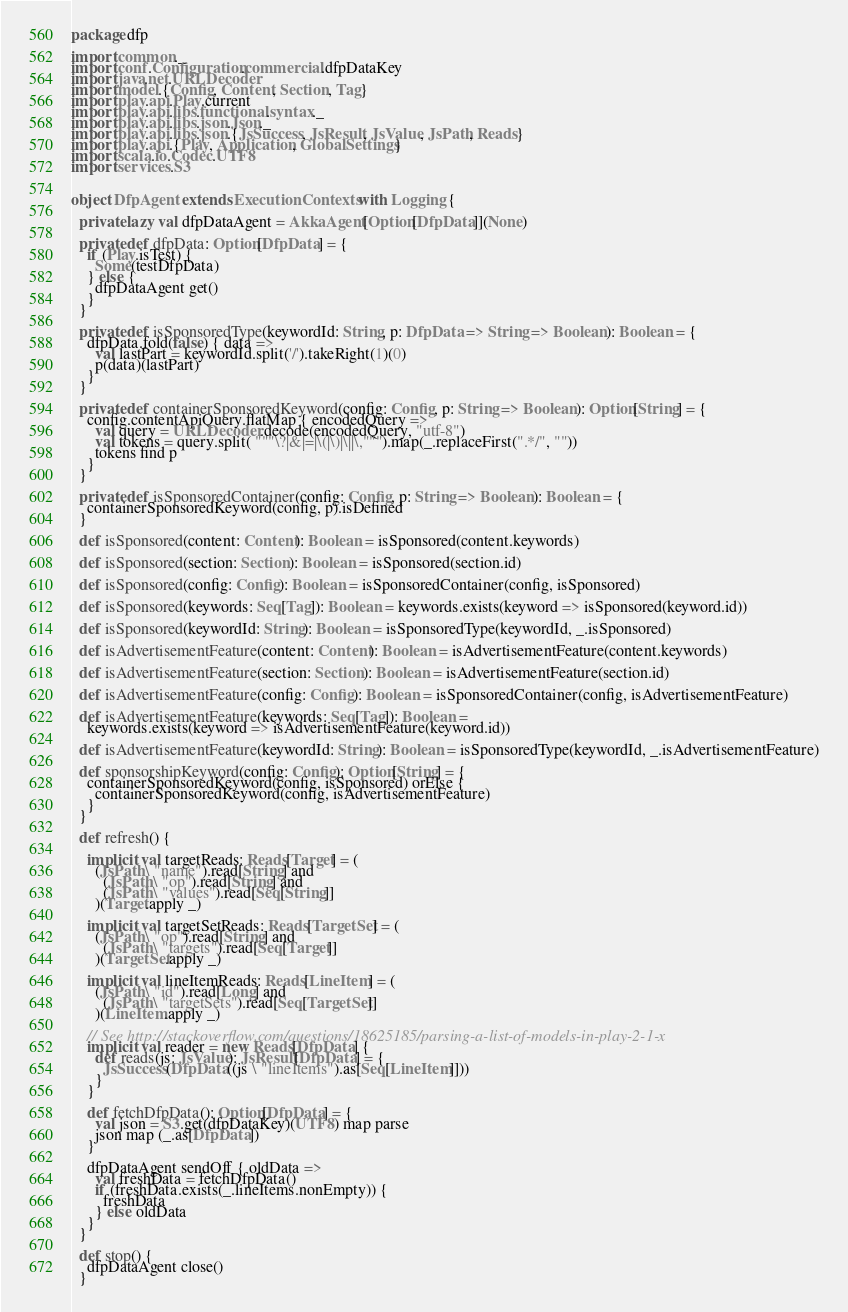<code> <loc_0><loc_0><loc_500><loc_500><_Scala_>package dfp

import common._
import conf.Configuration.commercial.dfpDataKey
import java.net.URLDecoder
import model.{Config, Content, Section, Tag}
import play.api.Play.current
import play.api.libs.functional.syntax._
import play.api.libs.json.Json._
import play.api.libs.json.{JsSuccess, JsResult, JsValue, JsPath, Reads}
import play.api.{Play, Application, GlobalSettings}
import scala.io.Codec.UTF8
import services.S3


object DfpAgent extends ExecutionContexts with Logging {

  private lazy val dfpDataAgent = AkkaAgent[Option[DfpData]](None)

  private def dfpData: Option[DfpData] = {
    if (Play.isTest) {
      Some(testDfpData)
    } else {
      dfpDataAgent get()
    }
  }

  private def isSponsoredType(keywordId: String, p: DfpData => String => Boolean): Boolean = {
    dfpData.fold(false) { data =>
      val lastPart = keywordId.split('/').takeRight(1)(0)
      p(data)(lastPart)
    }
  }

  private def containerSponsoredKeyword(config: Config, p: String => Boolean): Option[String] = {
    config.contentApiQuery.flatMap { encodedQuery =>
      val query = URLDecoder.decode(encodedQuery, "utf-8")
      val tokens = query.split( """\?|&|=|\(|\)|\||\,""").map(_.replaceFirst(".*/", ""))
      tokens find p
    }
  }

  private def isSponsoredContainer(config: Config, p: String => Boolean): Boolean = {
    containerSponsoredKeyword(config, p).isDefined
  }

  def isSponsored(content: Content): Boolean = isSponsored(content.keywords)

  def isSponsored(section: Section): Boolean = isSponsored(section.id)

  def isSponsored(config: Config): Boolean = isSponsoredContainer(config, isSponsored)

  def isSponsored(keywords: Seq[Tag]): Boolean = keywords.exists(keyword => isSponsored(keyword.id))

  def isSponsored(keywordId: String): Boolean = isSponsoredType(keywordId, _.isSponsored)

  def isAdvertisementFeature(content: Content): Boolean = isAdvertisementFeature(content.keywords)

  def isAdvertisementFeature(section: Section): Boolean = isAdvertisementFeature(section.id)

  def isAdvertisementFeature(config: Config): Boolean = isSponsoredContainer(config, isAdvertisementFeature)

  def isAdvertisementFeature(keywords: Seq[Tag]): Boolean =
    keywords.exists(keyword => isAdvertisementFeature(keyword.id))

  def isAdvertisementFeature(keywordId: String): Boolean = isSponsoredType(keywordId, _.isAdvertisementFeature)

  def sponsorshipKeyword(config: Config): Option[String] = {
    containerSponsoredKeyword(config, isSponsored) orElse {
      containerSponsoredKeyword(config, isAdvertisementFeature)
    }
  }

  def refresh() {

    implicit val targetReads: Reads[Target] = (
      (JsPath \ "name").read[String] and
        (JsPath \ "op").read[String] and
        (JsPath \ "values").read[Seq[String]]
      )(Target.apply _)

    implicit val targetSetReads: Reads[TargetSet] = (
      (JsPath \ "op").read[String] and
        (JsPath \ "targets").read[Seq[Target]]
      )(TargetSet.apply _)

    implicit val lineItemReads: Reads[LineItem] = (
      (JsPath \ "id").read[Long] and
        (JsPath \ "targetSets").read[Seq[TargetSet]]
      )(LineItem.apply _)

    // See http://stackoverflow.com/questions/18625185/parsing-a-list-of-models-in-play-2-1-x
    implicit val reader = new Reads[DfpData] {
      def reads(js: JsValue): JsResult[DfpData] = {
        JsSuccess(DfpData((js \ "lineItems").as[Seq[LineItem]]))
      }
    }

    def fetchDfpData(): Option[DfpData] = {
      val json = S3.get(dfpDataKey)(UTF8) map parse
      json map (_.as[DfpData])
    }

    dfpDataAgent sendOff { oldData =>
      val freshData = fetchDfpData()
      if (freshData.exists(_.lineItems.nonEmpty)) {
        freshData
      } else oldData
    }
  }

  def stop() {
    dfpDataAgent close()
  }
</code> 